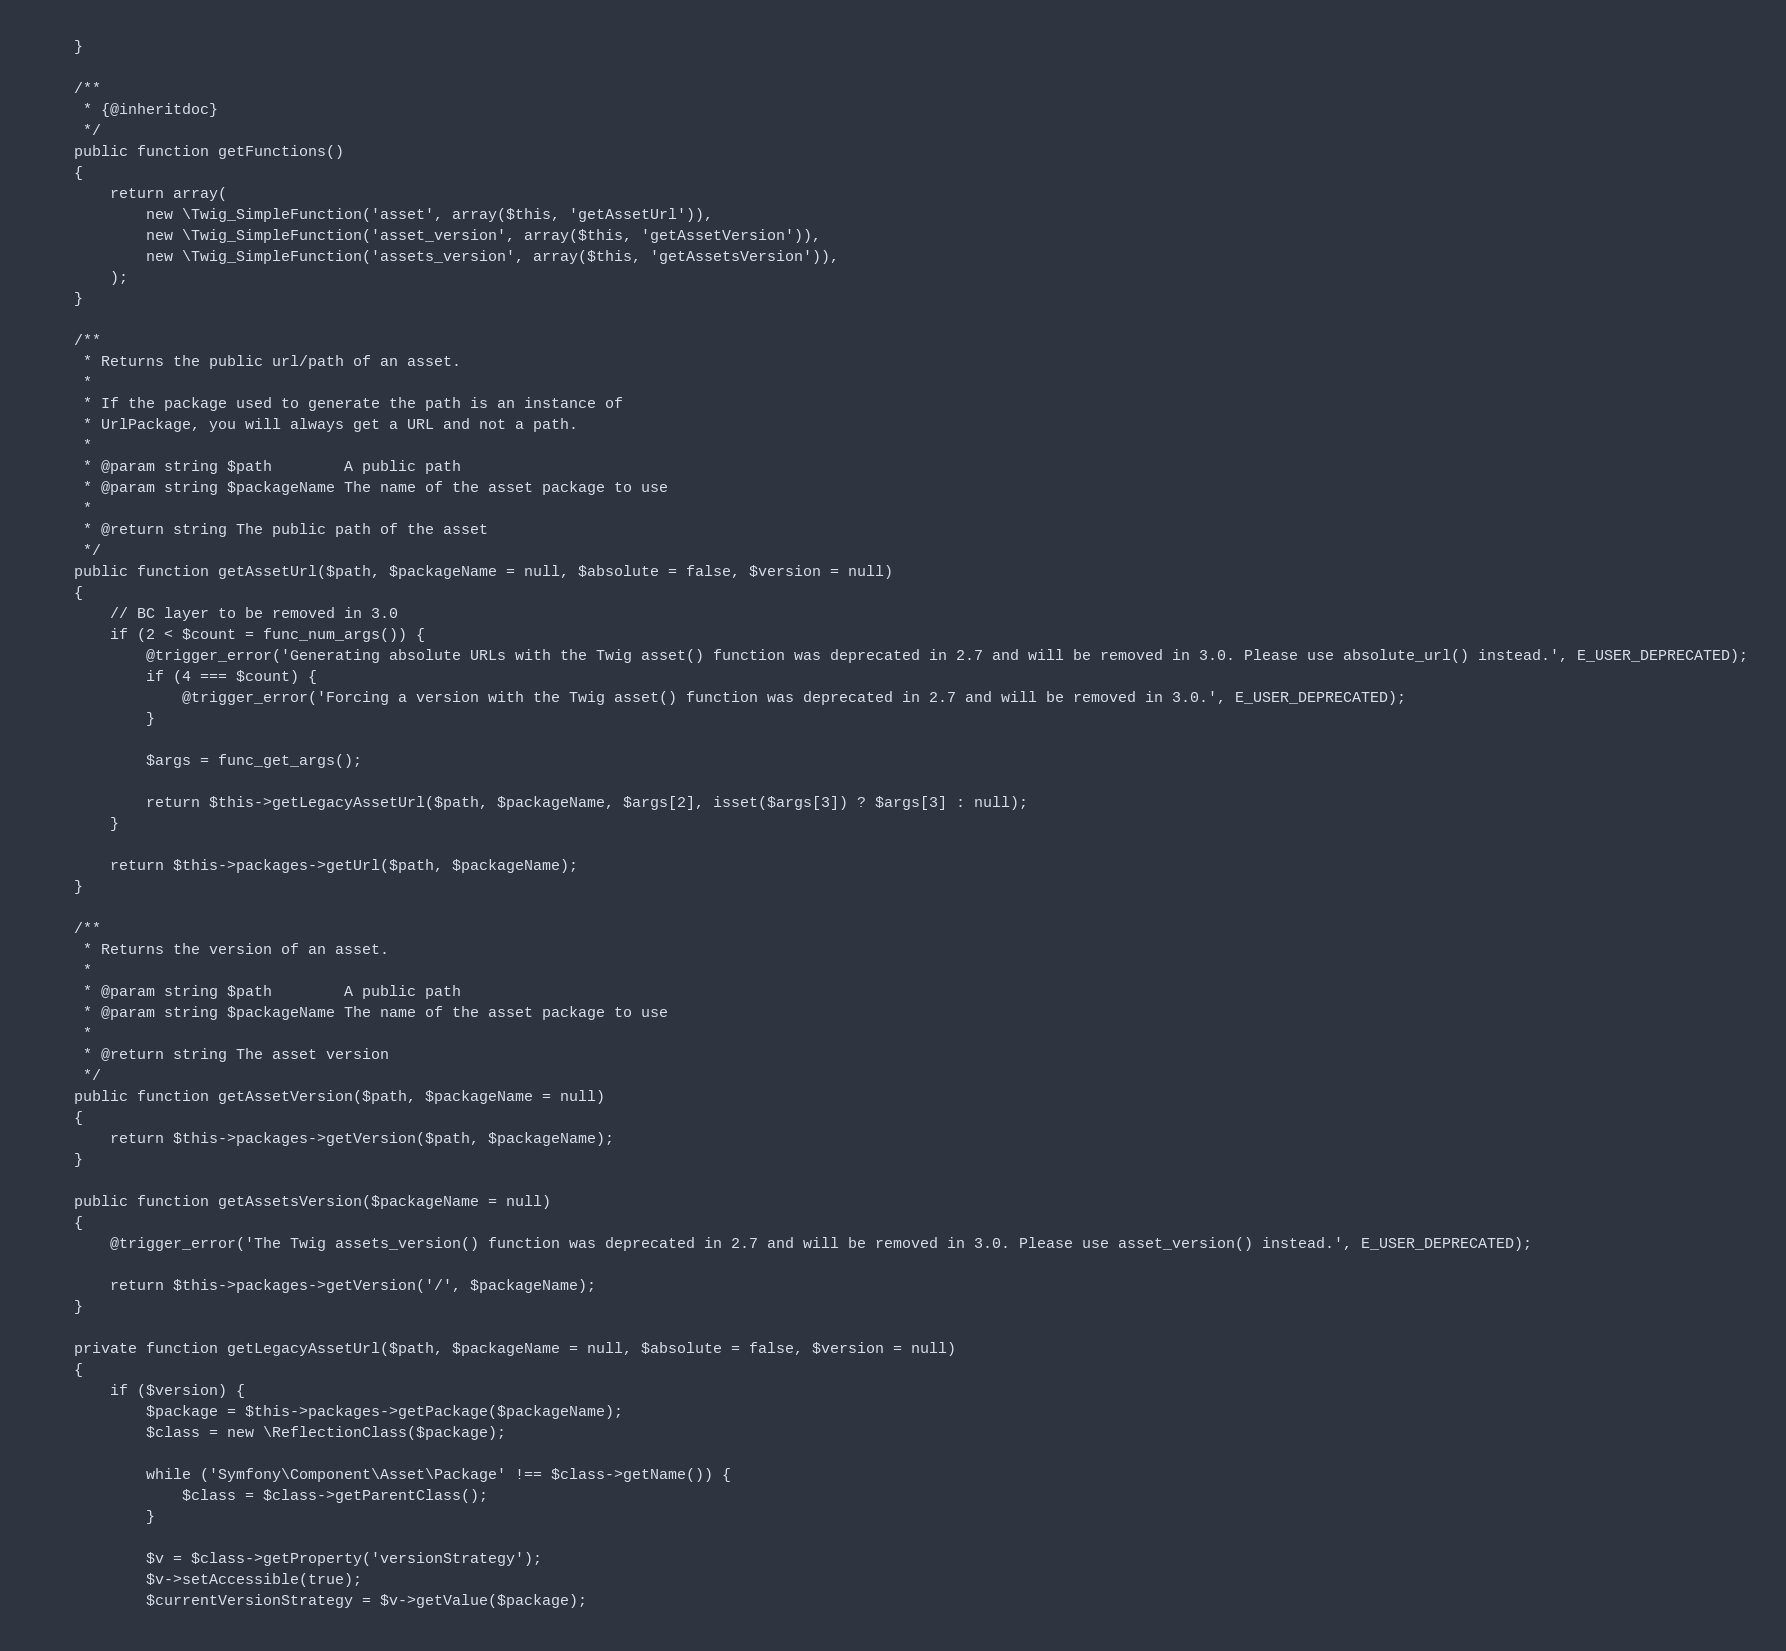<code> <loc_0><loc_0><loc_500><loc_500><_PHP_>    }

    /**
     * {@inheritdoc}
     */
    public function getFunctions()
    {
        return array(
            new \Twig_SimpleFunction('asset', array($this, 'getAssetUrl')),
            new \Twig_SimpleFunction('asset_version', array($this, 'getAssetVersion')),
            new \Twig_SimpleFunction('assets_version', array($this, 'getAssetsVersion')),
        );
    }

    /**
     * Returns the public url/path of an asset.
     *
     * If the package used to generate the path is an instance of
     * UrlPackage, you will always get a URL and not a path.
     *
     * @param string $path        A public path
     * @param string $packageName The name of the asset package to use
     *
     * @return string The public path of the asset
     */
    public function getAssetUrl($path, $packageName = null, $absolute = false, $version = null)
    {
        // BC layer to be removed in 3.0
        if (2 < $count = func_num_args()) {
            @trigger_error('Generating absolute URLs with the Twig asset() function was deprecated in 2.7 and will be removed in 3.0. Please use absolute_url() instead.', E_USER_DEPRECATED);
            if (4 === $count) {
                @trigger_error('Forcing a version with the Twig asset() function was deprecated in 2.7 and will be removed in 3.0.', E_USER_DEPRECATED);
            }

            $args = func_get_args();

            return $this->getLegacyAssetUrl($path, $packageName, $args[2], isset($args[3]) ? $args[3] : null);
        }

        return $this->packages->getUrl($path, $packageName);
    }

    /**
     * Returns the version of an asset.
     *
     * @param string $path        A public path
     * @param string $packageName The name of the asset package to use
     *
     * @return string The asset version
     */
    public function getAssetVersion($path, $packageName = null)
    {
        return $this->packages->getVersion($path, $packageName);
    }

    public function getAssetsVersion($packageName = null)
    {
        @trigger_error('The Twig assets_version() function was deprecated in 2.7 and will be removed in 3.0. Please use asset_version() instead.', E_USER_DEPRECATED);

        return $this->packages->getVersion('/', $packageName);
    }

    private function getLegacyAssetUrl($path, $packageName = null, $absolute = false, $version = null)
    {
        if ($version) {
            $package = $this->packages->getPackage($packageName);
            $class = new \ReflectionClass($package);

            while ('Symfony\Component\Asset\Package' !== $class->getName()) {
                $class = $class->getParentClass();
            }

            $v = $class->getProperty('versionStrategy');
            $v->setAccessible(true);
            $currentVersionStrategy = $v->getValue($package);
</code> 